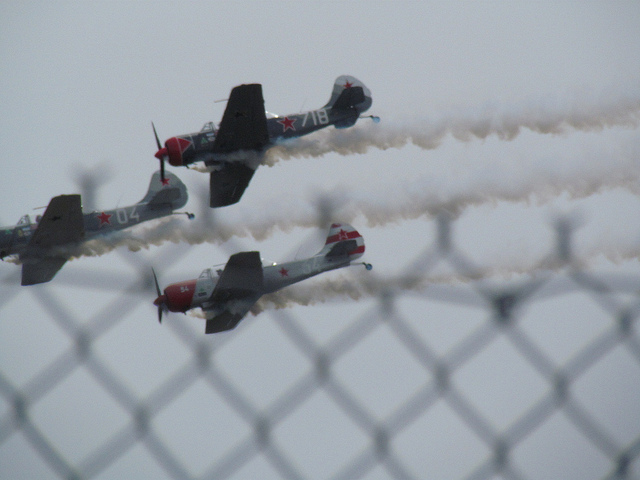Can you describe the types of airplanes shown in the image? The image shows three vintage military planes, possibly from the Cold War era, characterized by their robust designs and propeller-based engines. Do these types of planes have a specific historical significance? Yes, such planes typically have significant historical value, often used in military training and aerial combat. Their preservation and inclusion in air shows help educate and remind us of aviation history and technological advancements. 